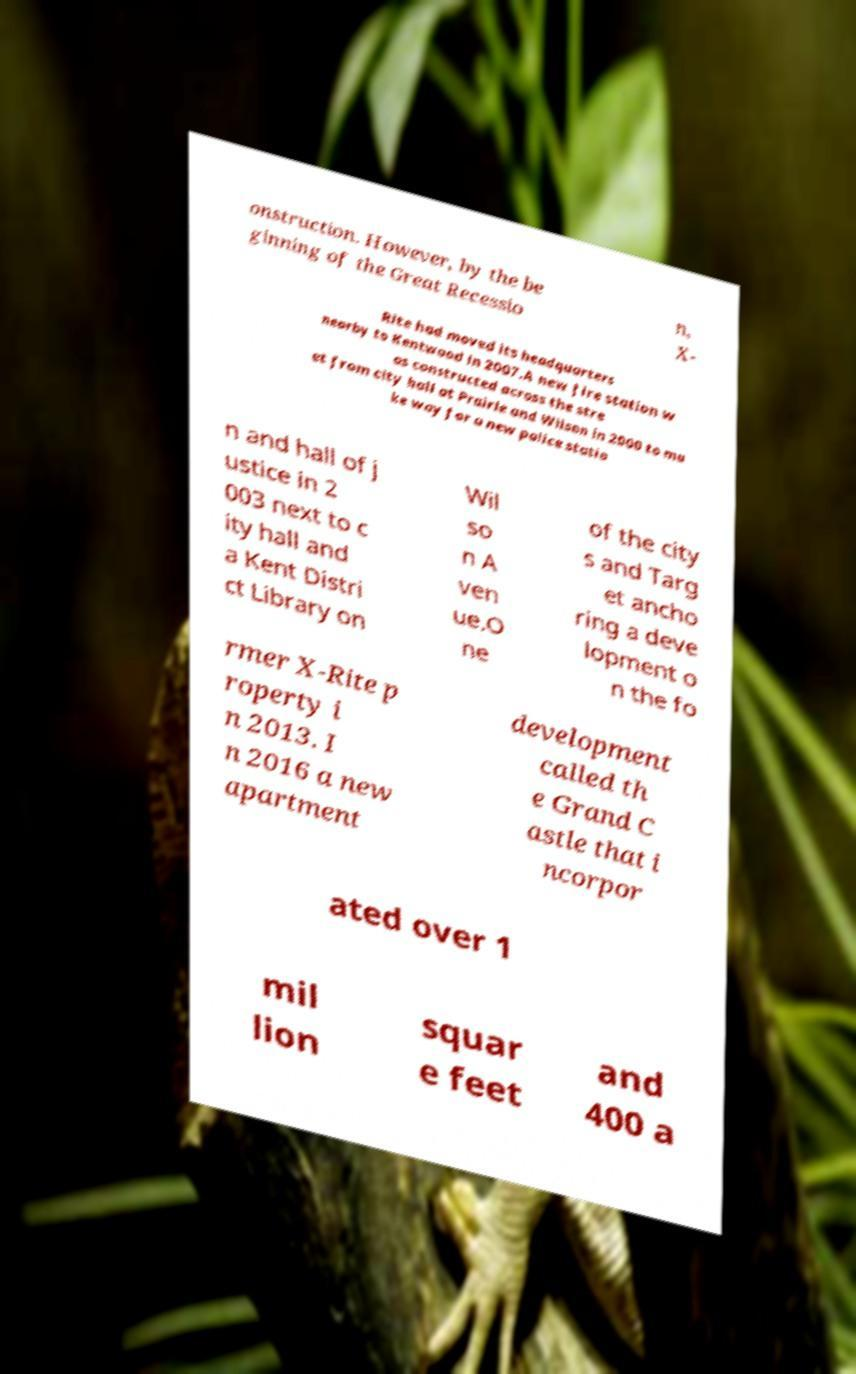Can you accurately transcribe the text from the provided image for me? onstruction. However, by the be ginning of the Great Recessio n, X- Rite had moved its headquarters nearby to Kentwood in 2007.A new fire station w as constructed across the stre et from city hall at Prairie and Wilson in 2000 to ma ke way for a new police statio n and hall of j ustice in 2 003 next to c ity hall and a Kent Distri ct Library on Wil so n A ven ue.O ne of the city s and Targ et ancho ring a deve lopment o n the fo rmer X-Rite p roperty i n 2013. I n 2016 a new apartment development called th e Grand C astle that i ncorpor ated over 1 mil lion squar e feet and 400 a 